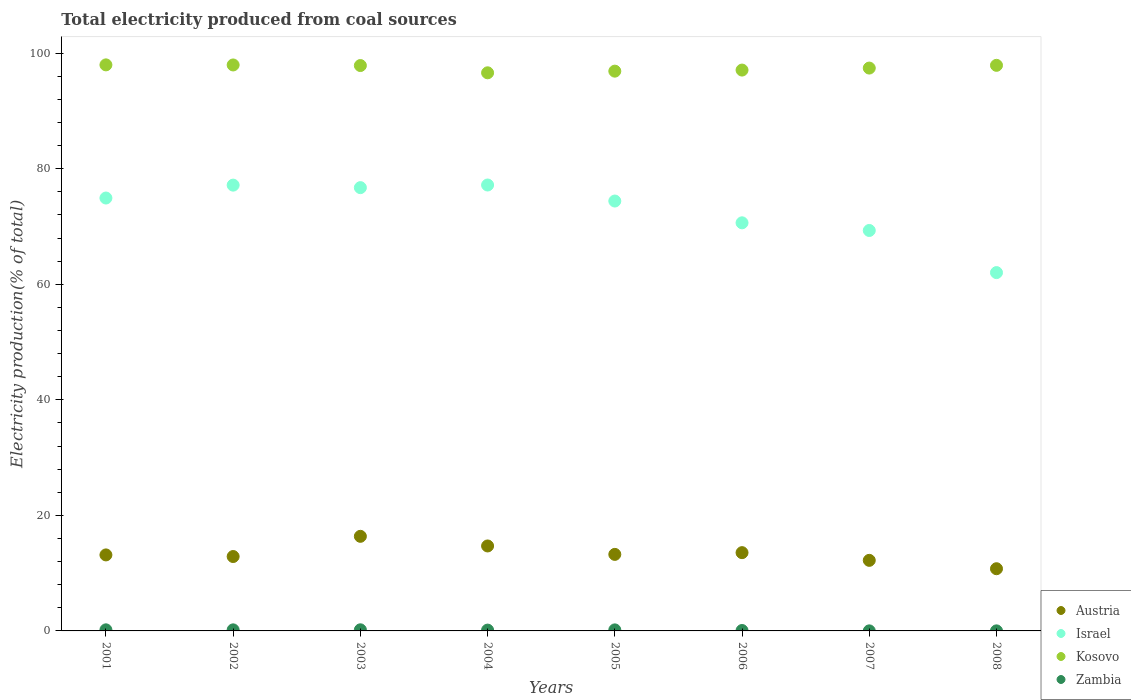What is the total electricity produced in Kosovo in 2007?
Keep it short and to the point. 97.41. Across all years, what is the maximum total electricity produced in Austria?
Make the answer very short. 16.37. Across all years, what is the minimum total electricity produced in Zambia?
Ensure brevity in your answer.  0.01. In which year was the total electricity produced in Austria minimum?
Provide a short and direct response. 2008. What is the total total electricity produced in Israel in the graph?
Provide a succinct answer. 582.33. What is the difference between the total electricity produced in Israel in 2001 and that in 2005?
Your answer should be very brief. 0.52. What is the difference between the total electricity produced in Zambia in 2002 and the total electricity produced in Israel in 2008?
Keep it short and to the point. -61.83. What is the average total electricity produced in Austria per year?
Give a very brief answer. 13.36. In the year 2005, what is the difference between the total electricity produced in Kosovo and total electricity produced in Austria?
Make the answer very short. 83.64. What is the ratio of the total electricity produced in Zambia in 2003 to that in 2004?
Give a very brief answer. 1.37. Is the difference between the total electricity produced in Kosovo in 2002 and 2006 greater than the difference between the total electricity produced in Austria in 2002 and 2006?
Give a very brief answer. Yes. What is the difference between the highest and the second highest total electricity produced in Kosovo?
Make the answer very short. 0.01. What is the difference between the highest and the lowest total electricity produced in Austria?
Give a very brief answer. 5.61. In how many years, is the total electricity produced in Kosovo greater than the average total electricity produced in Kosovo taken over all years?
Provide a succinct answer. 4. Is it the case that in every year, the sum of the total electricity produced in Austria and total electricity produced in Israel  is greater than the sum of total electricity produced in Zambia and total electricity produced in Kosovo?
Offer a very short reply. Yes. How many years are there in the graph?
Your answer should be compact. 8. What is the difference between two consecutive major ticks on the Y-axis?
Provide a short and direct response. 20. Are the values on the major ticks of Y-axis written in scientific E-notation?
Provide a succinct answer. No. Does the graph contain grids?
Give a very brief answer. No. Where does the legend appear in the graph?
Your answer should be very brief. Bottom right. How are the legend labels stacked?
Ensure brevity in your answer.  Vertical. What is the title of the graph?
Give a very brief answer. Total electricity produced from coal sources. Does "Bulgaria" appear as one of the legend labels in the graph?
Give a very brief answer. No. What is the label or title of the Y-axis?
Your answer should be compact. Electricity production(% of total). What is the Electricity production(% of total) in Austria in 2001?
Keep it short and to the point. 13.15. What is the Electricity production(% of total) in Israel in 2001?
Your response must be concise. 74.92. What is the Electricity production(% of total) of Kosovo in 2001?
Your answer should be very brief. 97.97. What is the Electricity production(% of total) in Zambia in 2001?
Ensure brevity in your answer.  0.19. What is the Electricity production(% of total) in Austria in 2002?
Offer a very short reply. 12.88. What is the Electricity production(% of total) in Israel in 2002?
Your response must be concise. 77.15. What is the Electricity production(% of total) of Kosovo in 2002?
Your response must be concise. 97.95. What is the Electricity production(% of total) of Zambia in 2002?
Offer a very short reply. 0.18. What is the Electricity production(% of total) of Austria in 2003?
Give a very brief answer. 16.37. What is the Electricity production(% of total) in Israel in 2003?
Keep it short and to the point. 76.72. What is the Electricity production(% of total) in Kosovo in 2003?
Provide a succinct answer. 97.85. What is the Electricity production(% of total) of Zambia in 2003?
Ensure brevity in your answer.  0.19. What is the Electricity production(% of total) of Austria in 2004?
Provide a short and direct response. 14.7. What is the Electricity production(% of total) in Israel in 2004?
Provide a short and direct response. 77.18. What is the Electricity production(% of total) of Kosovo in 2004?
Your answer should be very brief. 96.59. What is the Electricity production(% of total) in Zambia in 2004?
Your answer should be compact. 0.14. What is the Electricity production(% of total) in Austria in 2005?
Offer a terse response. 13.25. What is the Electricity production(% of total) of Israel in 2005?
Make the answer very short. 74.4. What is the Electricity production(% of total) in Kosovo in 2005?
Provide a succinct answer. 96.88. What is the Electricity production(% of total) of Zambia in 2005?
Keep it short and to the point. 0.18. What is the Electricity production(% of total) of Austria in 2006?
Your response must be concise. 13.55. What is the Electricity production(% of total) in Israel in 2006?
Offer a very short reply. 70.63. What is the Electricity production(% of total) in Kosovo in 2006?
Ensure brevity in your answer.  97.07. What is the Electricity production(% of total) in Zambia in 2006?
Your answer should be very brief. 0.07. What is the Electricity production(% of total) in Austria in 2007?
Ensure brevity in your answer.  12.21. What is the Electricity production(% of total) in Israel in 2007?
Give a very brief answer. 69.31. What is the Electricity production(% of total) of Kosovo in 2007?
Make the answer very short. 97.41. What is the Electricity production(% of total) in Zambia in 2007?
Ensure brevity in your answer.  0.01. What is the Electricity production(% of total) of Austria in 2008?
Offer a terse response. 10.76. What is the Electricity production(% of total) of Israel in 2008?
Ensure brevity in your answer.  62.02. What is the Electricity production(% of total) of Kosovo in 2008?
Offer a terse response. 97.89. What is the Electricity production(% of total) of Zambia in 2008?
Provide a succinct answer. 0.01. Across all years, what is the maximum Electricity production(% of total) of Austria?
Keep it short and to the point. 16.37. Across all years, what is the maximum Electricity production(% of total) in Israel?
Offer a very short reply. 77.18. Across all years, what is the maximum Electricity production(% of total) of Kosovo?
Offer a very short reply. 97.97. Across all years, what is the maximum Electricity production(% of total) in Zambia?
Provide a succinct answer. 0.19. Across all years, what is the minimum Electricity production(% of total) in Austria?
Offer a very short reply. 10.76. Across all years, what is the minimum Electricity production(% of total) of Israel?
Keep it short and to the point. 62.02. Across all years, what is the minimum Electricity production(% of total) in Kosovo?
Provide a succinct answer. 96.59. Across all years, what is the minimum Electricity production(% of total) in Zambia?
Offer a very short reply. 0.01. What is the total Electricity production(% of total) of Austria in the graph?
Your answer should be compact. 106.88. What is the total Electricity production(% of total) in Israel in the graph?
Keep it short and to the point. 582.33. What is the total Electricity production(% of total) in Kosovo in the graph?
Your response must be concise. 779.62. What is the total Electricity production(% of total) in Zambia in the graph?
Offer a very short reply. 0.98. What is the difference between the Electricity production(% of total) of Austria in 2001 and that in 2002?
Your response must be concise. 0.28. What is the difference between the Electricity production(% of total) in Israel in 2001 and that in 2002?
Provide a succinct answer. -2.23. What is the difference between the Electricity production(% of total) of Kosovo in 2001 and that in 2002?
Offer a terse response. 0.01. What is the difference between the Electricity production(% of total) of Zambia in 2001 and that in 2002?
Offer a very short reply. 0. What is the difference between the Electricity production(% of total) in Austria in 2001 and that in 2003?
Make the answer very short. -3.22. What is the difference between the Electricity production(% of total) in Israel in 2001 and that in 2003?
Keep it short and to the point. -1.8. What is the difference between the Electricity production(% of total) in Kosovo in 2001 and that in 2003?
Provide a short and direct response. 0.12. What is the difference between the Electricity production(% of total) in Zambia in 2001 and that in 2003?
Provide a succinct answer. -0. What is the difference between the Electricity production(% of total) of Austria in 2001 and that in 2004?
Provide a short and direct response. -1.55. What is the difference between the Electricity production(% of total) in Israel in 2001 and that in 2004?
Offer a terse response. -2.25. What is the difference between the Electricity production(% of total) of Kosovo in 2001 and that in 2004?
Make the answer very short. 1.37. What is the difference between the Electricity production(% of total) in Zambia in 2001 and that in 2004?
Offer a terse response. 0.05. What is the difference between the Electricity production(% of total) in Austria in 2001 and that in 2005?
Give a very brief answer. -0.09. What is the difference between the Electricity production(% of total) of Israel in 2001 and that in 2005?
Offer a very short reply. 0.52. What is the difference between the Electricity production(% of total) of Kosovo in 2001 and that in 2005?
Your response must be concise. 1.09. What is the difference between the Electricity production(% of total) of Zambia in 2001 and that in 2005?
Offer a very short reply. 0.01. What is the difference between the Electricity production(% of total) in Austria in 2001 and that in 2006?
Offer a very short reply. -0.39. What is the difference between the Electricity production(% of total) of Israel in 2001 and that in 2006?
Provide a succinct answer. 4.29. What is the difference between the Electricity production(% of total) of Kosovo in 2001 and that in 2006?
Offer a very short reply. 0.9. What is the difference between the Electricity production(% of total) in Zambia in 2001 and that in 2006?
Ensure brevity in your answer.  0.12. What is the difference between the Electricity production(% of total) in Austria in 2001 and that in 2007?
Offer a very short reply. 0.94. What is the difference between the Electricity production(% of total) of Israel in 2001 and that in 2007?
Provide a succinct answer. 5.62. What is the difference between the Electricity production(% of total) of Kosovo in 2001 and that in 2007?
Provide a succinct answer. 0.55. What is the difference between the Electricity production(% of total) of Zambia in 2001 and that in 2007?
Keep it short and to the point. 0.18. What is the difference between the Electricity production(% of total) in Austria in 2001 and that in 2008?
Keep it short and to the point. 2.39. What is the difference between the Electricity production(% of total) of Israel in 2001 and that in 2008?
Give a very brief answer. 12.91. What is the difference between the Electricity production(% of total) in Kosovo in 2001 and that in 2008?
Your answer should be compact. 0.08. What is the difference between the Electricity production(% of total) in Zambia in 2001 and that in 2008?
Provide a short and direct response. 0.18. What is the difference between the Electricity production(% of total) in Austria in 2002 and that in 2003?
Give a very brief answer. -3.5. What is the difference between the Electricity production(% of total) of Israel in 2002 and that in 2003?
Give a very brief answer. 0.43. What is the difference between the Electricity production(% of total) of Kosovo in 2002 and that in 2003?
Give a very brief answer. 0.1. What is the difference between the Electricity production(% of total) of Zambia in 2002 and that in 2003?
Make the answer very short. -0.01. What is the difference between the Electricity production(% of total) of Austria in 2002 and that in 2004?
Your answer should be very brief. -1.83. What is the difference between the Electricity production(% of total) in Israel in 2002 and that in 2004?
Offer a very short reply. -0.02. What is the difference between the Electricity production(% of total) in Kosovo in 2002 and that in 2004?
Offer a terse response. 1.36. What is the difference between the Electricity production(% of total) of Zambia in 2002 and that in 2004?
Your answer should be very brief. 0.04. What is the difference between the Electricity production(% of total) in Austria in 2002 and that in 2005?
Offer a very short reply. -0.37. What is the difference between the Electricity production(% of total) in Israel in 2002 and that in 2005?
Offer a terse response. 2.75. What is the difference between the Electricity production(% of total) of Kosovo in 2002 and that in 2005?
Give a very brief answer. 1.07. What is the difference between the Electricity production(% of total) of Zambia in 2002 and that in 2005?
Your answer should be very brief. 0.01. What is the difference between the Electricity production(% of total) in Austria in 2002 and that in 2006?
Offer a terse response. -0.67. What is the difference between the Electricity production(% of total) in Israel in 2002 and that in 2006?
Offer a very short reply. 6.52. What is the difference between the Electricity production(% of total) in Kosovo in 2002 and that in 2006?
Provide a succinct answer. 0.89. What is the difference between the Electricity production(% of total) of Zambia in 2002 and that in 2006?
Give a very brief answer. 0.11. What is the difference between the Electricity production(% of total) of Austria in 2002 and that in 2007?
Give a very brief answer. 0.66. What is the difference between the Electricity production(% of total) in Israel in 2002 and that in 2007?
Ensure brevity in your answer.  7.85. What is the difference between the Electricity production(% of total) of Kosovo in 2002 and that in 2007?
Your answer should be compact. 0.54. What is the difference between the Electricity production(% of total) of Zambia in 2002 and that in 2007?
Offer a terse response. 0.17. What is the difference between the Electricity production(% of total) of Austria in 2002 and that in 2008?
Ensure brevity in your answer.  2.11. What is the difference between the Electricity production(% of total) in Israel in 2002 and that in 2008?
Your answer should be compact. 15.14. What is the difference between the Electricity production(% of total) in Kosovo in 2002 and that in 2008?
Give a very brief answer. 0.07. What is the difference between the Electricity production(% of total) of Zambia in 2002 and that in 2008?
Ensure brevity in your answer.  0.17. What is the difference between the Electricity production(% of total) of Austria in 2003 and that in 2004?
Ensure brevity in your answer.  1.67. What is the difference between the Electricity production(% of total) in Israel in 2003 and that in 2004?
Your answer should be compact. -0.46. What is the difference between the Electricity production(% of total) of Kosovo in 2003 and that in 2004?
Make the answer very short. 1.26. What is the difference between the Electricity production(% of total) in Zambia in 2003 and that in 2004?
Your answer should be compact. 0.05. What is the difference between the Electricity production(% of total) of Austria in 2003 and that in 2005?
Provide a succinct answer. 3.13. What is the difference between the Electricity production(% of total) in Israel in 2003 and that in 2005?
Give a very brief answer. 2.32. What is the difference between the Electricity production(% of total) in Kosovo in 2003 and that in 2005?
Your response must be concise. 0.97. What is the difference between the Electricity production(% of total) of Zambia in 2003 and that in 2005?
Your answer should be very brief. 0.01. What is the difference between the Electricity production(% of total) in Austria in 2003 and that in 2006?
Ensure brevity in your answer.  2.83. What is the difference between the Electricity production(% of total) of Israel in 2003 and that in 2006?
Keep it short and to the point. 6.09. What is the difference between the Electricity production(% of total) of Kosovo in 2003 and that in 2006?
Give a very brief answer. 0.78. What is the difference between the Electricity production(% of total) in Zambia in 2003 and that in 2006?
Provide a succinct answer. 0.12. What is the difference between the Electricity production(% of total) of Austria in 2003 and that in 2007?
Your answer should be compact. 4.16. What is the difference between the Electricity production(% of total) in Israel in 2003 and that in 2007?
Give a very brief answer. 7.41. What is the difference between the Electricity production(% of total) in Kosovo in 2003 and that in 2007?
Your answer should be compact. 0.44. What is the difference between the Electricity production(% of total) in Zambia in 2003 and that in 2007?
Provide a succinct answer. 0.18. What is the difference between the Electricity production(% of total) of Austria in 2003 and that in 2008?
Offer a very short reply. 5.61. What is the difference between the Electricity production(% of total) in Israel in 2003 and that in 2008?
Provide a succinct answer. 14.7. What is the difference between the Electricity production(% of total) in Kosovo in 2003 and that in 2008?
Make the answer very short. -0.04. What is the difference between the Electricity production(% of total) in Zambia in 2003 and that in 2008?
Offer a very short reply. 0.18. What is the difference between the Electricity production(% of total) of Austria in 2004 and that in 2005?
Offer a very short reply. 1.46. What is the difference between the Electricity production(% of total) of Israel in 2004 and that in 2005?
Provide a succinct answer. 2.77. What is the difference between the Electricity production(% of total) of Kosovo in 2004 and that in 2005?
Offer a terse response. -0.29. What is the difference between the Electricity production(% of total) of Zambia in 2004 and that in 2005?
Ensure brevity in your answer.  -0.04. What is the difference between the Electricity production(% of total) of Austria in 2004 and that in 2006?
Your response must be concise. 1.16. What is the difference between the Electricity production(% of total) of Israel in 2004 and that in 2006?
Provide a succinct answer. 6.54. What is the difference between the Electricity production(% of total) of Kosovo in 2004 and that in 2006?
Your response must be concise. -0.47. What is the difference between the Electricity production(% of total) in Zambia in 2004 and that in 2006?
Give a very brief answer. 0.07. What is the difference between the Electricity production(% of total) of Austria in 2004 and that in 2007?
Offer a very short reply. 2.49. What is the difference between the Electricity production(% of total) of Israel in 2004 and that in 2007?
Provide a succinct answer. 7.87. What is the difference between the Electricity production(% of total) of Kosovo in 2004 and that in 2007?
Offer a very short reply. -0.82. What is the difference between the Electricity production(% of total) of Zambia in 2004 and that in 2007?
Your answer should be compact. 0.13. What is the difference between the Electricity production(% of total) in Austria in 2004 and that in 2008?
Give a very brief answer. 3.94. What is the difference between the Electricity production(% of total) of Israel in 2004 and that in 2008?
Your response must be concise. 15.16. What is the difference between the Electricity production(% of total) in Kosovo in 2004 and that in 2008?
Make the answer very short. -1.29. What is the difference between the Electricity production(% of total) of Zambia in 2004 and that in 2008?
Your answer should be compact. 0.13. What is the difference between the Electricity production(% of total) of Austria in 2005 and that in 2006?
Offer a terse response. -0.3. What is the difference between the Electricity production(% of total) of Israel in 2005 and that in 2006?
Keep it short and to the point. 3.77. What is the difference between the Electricity production(% of total) of Kosovo in 2005 and that in 2006?
Offer a very short reply. -0.19. What is the difference between the Electricity production(% of total) of Zambia in 2005 and that in 2006?
Provide a succinct answer. 0.11. What is the difference between the Electricity production(% of total) in Austria in 2005 and that in 2007?
Ensure brevity in your answer.  1.03. What is the difference between the Electricity production(% of total) of Israel in 2005 and that in 2007?
Your answer should be compact. 5.1. What is the difference between the Electricity production(% of total) in Kosovo in 2005 and that in 2007?
Provide a short and direct response. -0.53. What is the difference between the Electricity production(% of total) of Zambia in 2005 and that in 2007?
Offer a very short reply. 0.17. What is the difference between the Electricity production(% of total) in Austria in 2005 and that in 2008?
Give a very brief answer. 2.48. What is the difference between the Electricity production(% of total) of Israel in 2005 and that in 2008?
Provide a succinct answer. 12.39. What is the difference between the Electricity production(% of total) in Kosovo in 2005 and that in 2008?
Give a very brief answer. -1.01. What is the difference between the Electricity production(% of total) in Zambia in 2005 and that in 2008?
Give a very brief answer. 0.17. What is the difference between the Electricity production(% of total) in Austria in 2006 and that in 2007?
Provide a succinct answer. 1.33. What is the difference between the Electricity production(% of total) of Israel in 2006 and that in 2007?
Provide a succinct answer. 1.33. What is the difference between the Electricity production(% of total) in Kosovo in 2006 and that in 2007?
Ensure brevity in your answer.  -0.35. What is the difference between the Electricity production(% of total) in Zambia in 2006 and that in 2007?
Give a very brief answer. 0.06. What is the difference between the Electricity production(% of total) in Austria in 2006 and that in 2008?
Provide a succinct answer. 2.78. What is the difference between the Electricity production(% of total) in Israel in 2006 and that in 2008?
Ensure brevity in your answer.  8.62. What is the difference between the Electricity production(% of total) of Kosovo in 2006 and that in 2008?
Ensure brevity in your answer.  -0.82. What is the difference between the Electricity production(% of total) of Zambia in 2006 and that in 2008?
Offer a very short reply. 0.06. What is the difference between the Electricity production(% of total) of Austria in 2007 and that in 2008?
Provide a short and direct response. 1.45. What is the difference between the Electricity production(% of total) in Israel in 2007 and that in 2008?
Your response must be concise. 7.29. What is the difference between the Electricity production(% of total) in Kosovo in 2007 and that in 2008?
Provide a short and direct response. -0.47. What is the difference between the Electricity production(% of total) of Zambia in 2007 and that in 2008?
Make the answer very short. -0. What is the difference between the Electricity production(% of total) of Austria in 2001 and the Electricity production(% of total) of Israel in 2002?
Provide a succinct answer. -64. What is the difference between the Electricity production(% of total) of Austria in 2001 and the Electricity production(% of total) of Kosovo in 2002?
Keep it short and to the point. -84.8. What is the difference between the Electricity production(% of total) of Austria in 2001 and the Electricity production(% of total) of Zambia in 2002?
Give a very brief answer. 12.97. What is the difference between the Electricity production(% of total) of Israel in 2001 and the Electricity production(% of total) of Kosovo in 2002?
Your answer should be compact. -23.03. What is the difference between the Electricity production(% of total) of Israel in 2001 and the Electricity production(% of total) of Zambia in 2002?
Give a very brief answer. 74.74. What is the difference between the Electricity production(% of total) in Kosovo in 2001 and the Electricity production(% of total) in Zambia in 2002?
Offer a terse response. 97.78. What is the difference between the Electricity production(% of total) of Austria in 2001 and the Electricity production(% of total) of Israel in 2003?
Provide a short and direct response. -63.57. What is the difference between the Electricity production(% of total) of Austria in 2001 and the Electricity production(% of total) of Kosovo in 2003?
Keep it short and to the point. -84.7. What is the difference between the Electricity production(% of total) of Austria in 2001 and the Electricity production(% of total) of Zambia in 2003?
Give a very brief answer. 12.96. What is the difference between the Electricity production(% of total) of Israel in 2001 and the Electricity production(% of total) of Kosovo in 2003?
Provide a succinct answer. -22.93. What is the difference between the Electricity production(% of total) of Israel in 2001 and the Electricity production(% of total) of Zambia in 2003?
Provide a short and direct response. 74.73. What is the difference between the Electricity production(% of total) in Kosovo in 2001 and the Electricity production(% of total) in Zambia in 2003?
Give a very brief answer. 97.78. What is the difference between the Electricity production(% of total) of Austria in 2001 and the Electricity production(% of total) of Israel in 2004?
Offer a terse response. -64.02. What is the difference between the Electricity production(% of total) of Austria in 2001 and the Electricity production(% of total) of Kosovo in 2004?
Make the answer very short. -83.44. What is the difference between the Electricity production(% of total) in Austria in 2001 and the Electricity production(% of total) in Zambia in 2004?
Offer a terse response. 13.01. What is the difference between the Electricity production(% of total) of Israel in 2001 and the Electricity production(% of total) of Kosovo in 2004?
Provide a succinct answer. -21.67. What is the difference between the Electricity production(% of total) of Israel in 2001 and the Electricity production(% of total) of Zambia in 2004?
Keep it short and to the point. 74.78. What is the difference between the Electricity production(% of total) of Kosovo in 2001 and the Electricity production(% of total) of Zambia in 2004?
Make the answer very short. 97.83. What is the difference between the Electricity production(% of total) of Austria in 2001 and the Electricity production(% of total) of Israel in 2005?
Provide a short and direct response. -61.25. What is the difference between the Electricity production(% of total) in Austria in 2001 and the Electricity production(% of total) in Kosovo in 2005?
Provide a succinct answer. -83.73. What is the difference between the Electricity production(% of total) of Austria in 2001 and the Electricity production(% of total) of Zambia in 2005?
Your response must be concise. 12.98. What is the difference between the Electricity production(% of total) of Israel in 2001 and the Electricity production(% of total) of Kosovo in 2005?
Provide a short and direct response. -21.96. What is the difference between the Electricity production(% of total) in Israel in 2001 and the Electricity production(% of total) in Zambia in 2005?
Your answer should be very brief. 74.74. What is the difference between the Electricity production(% of total) of Kosovo in 2001 and the Electricity production(% of total) of Zambia in 2005?
Ensure brevity in your answer.  97.79. What is the difference between the Electricity production(% of total) in Austria in 2001 and the Electricity production(% of total) in Israel in 2006?
Offer a very short reply. -57.48. What is the difference between the Electricity production(% of total) in Austria in 2001 and the Electricity production(% of total) in Kosovo in 2006?
Provide a succinct answer. -83.91. What is the difference between the Electricity production(% of total) in Austria in 2001 and the Electricity production(% of total) in Zambia in 2006?
Your answer should be very brief. 13.08. What is the difference between the Electricity production(% of total) of Israel in 2001 and the Electricity production(% of total) of Kosovo in 2006?
Your answer should be compact. -22.15. What is the difference between the Electricity production(% of total) in Israel in 2001 and the Electricity production(% of total) in Zambia in 2006?
Provide a short and direct response. 74.85. What is the difference between the Electricity production(% of total) in Kosovo in 2001 and the Electricity production(% of total) in Zambia in 2006?
Give a very brief answer. 97.9. What is the difference between the Electricity production(% of total) in Austria in 2001 and the Electricity production(% of total) in Israel in 2007?
Make the answer very short. -56.15. What is the difference between the Electricity production(% of total) of Austria in 2001 and the Electricity production(% of total) of Kosovo in 2007?
Provide a short and direct response. -84.26. What is the difference between the Electricity production(% of total) in Austria in 2001 and the Electricity production(% of total) in Zambia in 2007?
Give a very brief answer. 13.14. What is the difference between the Electricity production(% of total) of Israel in 2001 and the Electricity production(% of total) of Kosovo in 2007?
Your answer should be compact. -22.49. What is the difference between the Electricity production(% of total) in Israel in 2001 and the Electricity production(% of total) in Zambia in 2007?
Offer a terse response. 74.91. What is the difference between the Electricity production(% of total) of Kosovo in 2001 and the Electricity production(% of total) of Zambia in 2007?
Your answer should be very brief. 97.96. What is the difference between the Electricity production(% of total) of Austria in 2001 and the Electricity production(% of total) of Israel in 2008?
Your answer should be compact. -48.86. What is the difference between the Electricity production(% of total) of Austria in 2001 and the Electricity production(% of total) of Kosovo in 2008?
Offer a very short reply. -84.73. What is the difference between the Electricity production(% of total) of Austria in 2001 and the Electricity production(% of total) of Zambia in 2008?
Your answer should be very brief. 13.14. What is the difference between the Electricity production(% of total) in Israel in 2001 and the Electricity production(% of total) in Kosovo in 2008?
Provide a short and direct response. -22.97. What is the difference between the Electricity production(% of total) of Israel in 2001 and the Electricity production(% of total) of Zambia in 2008?
Give a very brief answer. 74.91. What is the difference between the Electricity production(% of total) in Kosovo in 2001 and the Electricity production(% of total) in Zambia in 2008?
Your response must be concise. 97.96. What is the difference between the Electricity production(% of total) in Austria in 2002 and the Electricity production(% of total) in Israel in 2003?
Provide a succinct answer. -63.84. What is the difference between the Electricity production(% of total) in Austria in 2002 and the Electricity production(% of total) in Kosovo in 2003?
Ensure brevity in your answer.  -84.97. What is the difference between the Electricity production(% of total) of Austria in 2002 and the Electricity production(% of total) of Zambia in 2003?
Your answer should be very brief. 12.68. What is the difference between the Electricity production(% of total) of Israel in 2002 and the Electricity production(% of total) of Kosovo in 2003?
Offer a very short reply. -20.7. What is the difference between the Electricity production(% of total) in Israel in 2002 and the Electricity production(% of total) in Zambia in 2003?
Provide a short and direct response. 76.96. What is the difference between the Electricity production(% of total) in Kosovo in 2002 and the Electricity production(% of total) in Zambia in 2003?
Keep it short and to the point. 97.76. What is the difference between the Electricity production(% of total) of Austria in 2002 and the Electricity production(% of total) of Israel in 2004?
Offer a very short reply. -64.3. What is the difference between the Electricity production(% of total) in Austria in 2002 and the Electricity production(% of total) in Kosovo in 2004?
Offer a terse response. -83.72. What is the difference between the Electricity production(% of total) in Austria in 2002 and the Electricity production(% of total) in Zambia in 2004?
Your answer should be very brief. 12.74. What is the difference between the Electricity production(% of total) in Israel in 2002 and the Electricity production(% of total) in Kosovo in 2004?
Ensure brevity in your answer.  -19.44. What is the difference between the Electricity production(% of total) in Israel in 2002 and the Electricity production(% of total) in Zambia in 2004?
Your response must be concise. 77.01. What is the difference between the Electricity production(% of total) in Kosovo in 2002 and the Electricity production(% of total) in Zambia in 2004?
Your answer should be very brief. 97.81. What is the difference between the Electricity production(% of total) of Austria in 2002 and the Electricity production(% of total) of Israel in 2005?
Your answer should be compact. -61.53. What is the difference between the Electricity production(% of total) of Austria in 2002 and the Electricity production(% of total) of Kosovo in 2005?
Your answer should be compact. -84.01. What is the difference between the Electricity production(% of total) in Austria in 2002 and the Electricity production(% of total) in Zambia in 2005?
Make the answer very short. 12.7. What is the difference between the Electricity production(% of total) of Israel in 2002 and the Electricity production(% of total) of Kosovo in 2005?
Offer a very short reply. -19.73. What is the difference between the Electricity production(% of total) of Israel in 2002 and the Electricity production(% of total) of Zambia in 2005?
Your response must be concise. 76.97. What is the difference between the Electricity production(% of total) in Kosovo in 2002 and the Electricity production(% of total) in Zambia in 2005?
Make the answer very short. 97.78. What is the difference between the Electricity production(% of total) of Austria in 2002 and the Electricity production(% of total) of Israel in 2006?
Give a very brief answer. -57.75. What is the difference between the Electricity production(% of total) of Austria in 2002 and the Electricity production(% of total) of Kosovo in 2006?
Give a very brief answer. -84.19. What is the difference between the Electricity production(% of total) in Austria in 2002 and the Electricity production(% of total) in Zambia in 2006?
Your answer should be very brief. 12.81. What is the difference between the Electricity production(% of total) in Israel in 2002 and the Electricity production(% of total) in Kosovo in 2006?
Your response must be concise. -19.91. What is the difference between the Electricity production(% of total) in Israel in 2002 and the Electricity production(% of total) in Zambia in 2006?
Your response must be concise. 77.08. What is the difference between the Electricity production(% of total) in Kosovo in 2002 and the Electricity production(% of total) in Zambia in 2006?
Keep it short and to the point. 97.88. What is the difference between the Electricity production(% of total) in Austria in 2002 and the Electricity production(% of total) in Israel in 2007?
Provide a short and direct response. -56.43. What is the difference between the Electricity production(% of total) of Austria in 2002 and the Electricity production(% of total) of Kosovo in 2007?
Your answer should be very brief. -84.54. What is the difference between the Electricity production(% of total) in Austria in 2002 and the Electricity production(% of total) in Zambia in 2007?
Your answer should be very brief. 12.87. What is the difference between the Electricity production(% of total) in Israel in 2002 and the Electricity production(% of total) in Kosovo in 2007?
Ensure brevity in your answer.  -20.26. What is the difference between the Electricity production(% of total) of Israel in 2002 and the Electricity production(% of total) of Zambia in 2007?
Your answer should be very brief. 77.14. What is the difference between the Electricity production(% of total) in Kosovo in 2002 and the Electricity production(% of total) in Zambia in 2007?
Give a very brief answer. 97.94. What is the difference between the Electricity production(% of total) in Austria in 2002 and the Electricity production(% of total) in Israel in 2008?
Provide a succinct answer. -49.14. What is the difference between the Electricity production(% of total) of Austria in 2002 and the Electricity production(% of total) of Kosovo in 2008?
Provide a succinct answer. -85.01. What is the difference between the Electricity production(% of total) in Austria in 2002 and the Electricity production(% of total) in Zambia in 2008?
Make the answer very short. 12.87. What is the difference between the Electricity production(% of total) of Israel in 2002 and the Electricity production(% of total) of Kosovo in 2008?
Offer a very short reply. -20.73. What is the difference between the Electricity production(% of total) of Israel in 2002 and the Electricity production(% of total) of Zambia in 2008?
Make the answer very short. 77.14. What is the difference between the Electricity production(% of total) in Kosovo in 2002 and the Electricity production(% of total) in Zambia in 2008?
Make the answer very short. 97.94. What is the difference between the Electricity production(% of total) of Austria in 2003 and the Electricity production(% of total) of Israel in 2004?
Your answer should be compact. -60.8. What is the difference between the Electricity production(% of total) in Austria in 2003 and the Electricity production(% of total) in Kosovo in 2004?
Make the answer very short. -80.22. What is the difference between the Electricity production(% of total) of Austria in 2003 and the Electricity production(% of total) of Zambia in 2004?
Make the answer very short. 16.23. What is the difference between the Electricity production(% of total) in Israel in 2003 and the Electricity production(% of total) in Kosovo in 2004?
Provide a succinct answer. -19.87. What is the difference between the Electricity production(% of total) of Israel in 2003 and the Electricity production(% of total) of Zambia in 2004?
Your answer should be compact. 76.58. What is the difference between the Electricity production(% of total) of Kosovo in 2003 and the Electricity production(% of total) of Zambia in 2004?
Provide a succinct answer. 97.71. What is the difference between the Electricity production(% of total) of Austria in 2003 and the Electricity production(% of total) of Israel in 2005?
Your response must be concise. -58.03. What is the difference between the Electricity production(% of total) in Austria in 2003 and the Electricity production(% of total) in Kosovo in 2005?
Keep it short and to the point. -80.51. What is the difference between the Electricity production(% of total) of Austria in 2003 and the Electricity production(% of total) of Zambia in 2005?
Your answer should be very brief. 16.19. What is the difference between the Electricity production(% of total) of Israel in 2003 and the Electricity production(% of total) of Kosovo in 2005?
Your answer should be compact. -20.16. What is the difference between the Electricity production(% of total) in Israel in 2003 and the Electricity production(% of total) in Zambia in 2005?
Your response must be concise. 76.54. What is the difference between the Electricity production(% of total) in Kosovo in 2003 and the Electricity production(% of total) in Zambia in 2005?
Your answer should be very brief. 97.67. What is the difference between the Electricity production(% of total) in Austria in 2003 and the Electricity production(% of total) in Israel in 2006?
Your answer should be compact. -54.26. What is the difference between the Electricity production(% of total) in Austria in 2003 and the Electricity production(% of total) in Kosovo in 2006?
Ensure brevity in your answer.  -80.7. What is the difference between the Electricity production(% of total) in Austria in 2003 and the Electricity production(% of total) in Zambia in 2006?
Your answer should be very brief. 16.3. What is the difference between the Electricity production(% of total) in Israel in 2003 and the Electricity production(% of total) in Kosovo in 2006?
Give a very brief answer. -20.35. What is the difference between the Electricity production(% of total) in Israel in 2003 and the Electricity production(% of total) in Zambia in 2006?
Provide a short and direct response. 76.65. What is the difference between the Electricity production(% of total) in Kosovo in 2003 and the Electricity production(% of total) in Zambia in 2006?
Your answer should be very brief. 97.78. What is the difference between the Electricity production(% of total) of Austria in 2003 and the Electricity production(% of total) of Israel in 2007?
Your response must be concise. -52.93. What is the difference between the Electricity production(% of total) of Austria in 2003 and the Electricity production(% of total) of Kosovo in 2007?
Provide a short and direct response. -81.04. What is the difference between the Electricity production(% of total) of Austria in 2003 and the Electricity production(% of total) of Zambia in 2007?
Offer a very short reply. 16.36. What is the difference between the Electricity production(% of total) of Israel in 2003 and the Electricity production(% of total) of Kosovo in 2007?
Your answer should be very brief. -20.69. What is the difference between the Electricity production(% of total) in Israel in 2003 and the Electricity production(% of total) in Zambia in 2007?
Offer a terse response. 76.71. What is the difference between the Electricity production(% of total) of Kosovo in 2003 and the Electricity production(% of total) of Zambia in 2007?
Your response must be concise. 97.84. What is the difference between the Electricity production(% of total) of Austria in 2003 and the Electricity production(% of total) of Israel in 2008?
Your answer should be compact. -45.64. What is the difference between the Electricity production(% of total) in Austria in 2003 and the Electricity production(% of total) in Kosovo in 2008?
Make the answer very short. -81.52. What is the difference between the Electricity production(% of total) in Austria in 2003 and the Electricity production(% of total) in Zambia in 2008?
Make the answer very short. 16.36. What is the difference between the Electricity production(% of total) in Israel in 2003 and the Electricity production(% of total) in Kosovo in 2008?
Provide a succinct answer. -21.17. What is the difference between the Electricity production(% of total) in Israel in 2003 and the Electricity production(% of total) in Zambia in 2008?
Your answer should be compact. 76.71. What is the difference between the Electricity production(% of total) in Kosovo in 2003 and the Electricity production(% of total) in Zambia in 2008?
Give a very brief answer. 97.84. What is the difference between the Electricity production(% of total) of Austria in 2004 and the Electricity production(% of total) of Israel in 2005?
Offer a very short reply. -59.7. What is the difference between the Electricity production(% of total) in Austria in 2004 and the Electricity production(% of total) in Kosovo in 2005?
Ensure brevity in your answer.  -82.18. What is the difference between the Electricity production(% of total) of Austria in 2004 and the Electricity production(% of total) of Zambia in 2005?
Give a very brief answer. 14.53. What is the difference between the Electricity production(% of total) in Israel in 2004 and the Electricity production(% of total) in Kosovo in 2005?
Provide a short and direct response. -19.71. What is the difference between the Electricity production(% of total) of Israel in 2004 and the Electricity production(% of total) of Zambia in 2005?
Provide a succinct answer. 77. What is the difference between the Electricity production(% of total) of Kosovo in 2004 and the Electricity production(% of total) of Zambia in 2005?
Ensure brevity in your answer.  96.42. What is the difference between the Electricity production(% of total) of Austria in 2004 and the Electricity production(% of total) of Israel in 2006?
Ensure brevity in your answer.  -55.93. What is the difference between the Electricity production(% of total) in Austria in 2004 and the Electricity production(% of total) in Kosovo in 2006?
Give a very brief answer. -82.36. What is the difference between the Electricity production(% of total) of Austria in 2004 and the Electricity production(% of total) of Zambia in 2006?
Offer a very short reply. 14.63. What is the difference between the Electricity production(% of total) of Israel in 2004 and the Electricity production(% of total) of Kosovo in 2006?
Offer a very short reply. -19.89. What is the difference between the Electricity production(% of total) of Israel in 2004 and the Electricity production(% of total) of Zambia in 2006?
Provide a short and direct response. 77.11. What is the difference between the Electricity production(% of total) of Kosovo in 2004 and the Electricity production(% of total) of Zambia in 2006?
Your answer should be compact. 96.52. What is the difference between the Electricity production(% of total) in Austria in 2004 and the Electricity production(% of total) in Israel in 2007?
Provide a short and direct response. -54.6. What is the difference between the Electricity production(% of total) in Austria in 2004 and the Electricity production(% of total) in Kosovo in 2007?
Give a very brief answer. -82.71. What is the difference between the Electricity production(% of total) of Austria in 2004 and the Electricity production(% of total) of Zambia in 2007?
Give a very brief answer. 14.69. What is the difference between the Electricity production(% of total) of Israel in 2004 and the Electricity production(% of total) of Kosovo in 2007?
Offer a very short reply. -20.24. What is the difference between the Electricity production(% of total) in Israel in 2004 and the Electricity production(% of total) in Zambia in 2007?
Keep it short and to the point. 77.17. What is the difference between the Electricity production(% of total) in Kosovo in 2004 and the Electricity production(% of total) in Zambia in 2007?
Offer a terse response. 96.58. What is the difference between the Electricity production(% of total) in Austria in 2004 and the Electricity production(% of total) in Israel in 2008?
Your answer should be compact. -47.31. What is the difference between the Electricity production(% of total) in Austria in 2004 and the Electricity production(% of total) in Kosovo in 2008?
Ensure brevity in your answer.  -83.18. What is the difference between the Electricity production(% of total) in Austria in 2004 and the Electricity production(% of total) in Zambia in 2008?
Provide a succinct answer. 14.69. What is the difference between the Electricity production(% of total) in Israel in 2004 and the Electricity production(% of total) in Kosovo in 2008?
Your response must be concise. -20.71. What is the difference between the Electricity production(% of total) in Israel in 2004 and the Electricity production(% of total) in Zambia in 2008?
Keep it short and to the point. 77.17. What is the difference between the Electricity production(% of total) of Kosovo in 2004 and the Electricity production(% of total) of Zambia in 2008?
Your response must be concise. 96.58. What is the difference between the Electricity production(% of total) in Austria in 2005 and the Electricity production(% of total) in Israel in 2006?
Your response must be concise. -57.39. What is the difference between the Electricity production(% of total) in Austria in 2005 and the Electricity production(% of total) in Kosovo in 2006?
Your response must be concise. -83.82. What is the difference between the Electricity production(% of total) of Austria in 2005 and the Electricity production(% of total) of Zambia in 2006?
Make the answer very short. 13.17. What is the difference between the Electricity production(% of total) in Israel in 2005 and the Electricity production(% of total) in Kosovo in 2006?
Keep it short and to the point. -22.67. What is the difference between the Electricity production(% of total) of Israel in 2005 and the Electricity production(% of total) of Zambia in 2006?
Provide a succinct answer. 74.33. What is the difference between the Electricity production(% of total) in Kosovo in 2005 and the Electricity production(% of total) in Zambia in 2006?
Give a very brief answer. 96.81. What is the difference between the Electricity production(% of total) of Austria in 2005 and the Electricity production(% of total) of Israel in 2007?
Offer a very short reply. -56.06. What is the difference between the Electricity production(% of total) of Austria in 2005 and the Electricity production(% of total) of Kosovo in 2007?
Make the answer very short. -84.17. What is the difference between the Electricity production(% of total) of Austria in 2005 and the Electricity production(% of total) of Zambia in 2007?
Give a very brief answer. 13.24. What is the difference between the Electricity production(% of total) in Israel in 2005 and the Electricity production(% of total) in Kosovo in 2007?
Your answer should be very brief. -23.01. What is the difference between the Electricity production(% of total) of Israel in 2005 and the Electricity production(% of total) of Zambia in 2007?
Give a very brief answer. 74.39. What is the difference between the Electricity production(% of total) of Kosovo in 2005 and the Electricity production(% of total) of Zambia in 2007?
Make the answer very short. 96.87. What is the difference between the Electricity production(% of total) in Austria in 2005 and the Electricity production(% of total) in Israel in 2008?
Your response must be concise. -48.77. What is the difference between the Electricity production(% of total) of Austria in 2005 and the Electricity production(% of total) of Kosovo in 2008?
Your answer should be compact. -84.64. What is the difference between the Electricity production(% of total) of Austria in 2005 and the Electricity production(% of total) of Zambia in 2008?
Keep it short and to the point. 13.24. What is the difference between the Electricity production(% of total) of Israel in 2005 and the Electricity production(% of total) of Kosovo in 2008?
Your response must be concise. -23.49. What is the difference between the Electricity production(% of total) of Israel in 2005 and the Electricity production(% of total) of Zambia in 2008?
Give a very brief answer. 74.39. What is the difference between the Electricity production(% of total) of Kosovo in 2005 and the Electricity production(% of total) of Zambia in 2008?
Offer a terse response. 96.87. What is the difference between the Electricity production(% of total) of Austria in 2006 and the Electricity production(% of total) of Israel in 2007?
Your answer should be very brief. -55.76. What is the difference between the Electricity production(% of total) of Austria in 2006 and the Electricity production(% of total) of Kosovo in 2007?
Give a very brief answer. -83.87. What is the difference between the Electricity production(% of total) in Austria in 2006 and the Electricity production(% of total) in Zambia in 2007?
Ensure brevity in your answer.  13.54. What is the difference between the Electricity production(% of total) of Israel in 2006 and the Electricity production(% of total) of Kosovo in 2007?
Your answer should be very brief. -26.78. What is the difference between the Electricity production(% of total) of Israel in 2006 and the Electricity production(% of total) of Zambia in 2007?
Your answer should be very brief. 70.62. What is the difference between the Electricity production(% of total) of Kosovo in 2006 and the Electricity production(% of total) of Zambia in 2007?
Offer a terse response. 97.06. What is the difference between the Electricity production(% of total) of Austria in 2006 and the Electricity production(% of total) of Israel in 2008?
Your response must be concise. -48.47. What is the difference between the Electricity production(% of total) in Austria in 2006 and the Electricity production(% of total) in Kosovo in 2008?
Offer a terse response. -84.34. What is the difference between the Electricity production(% of total) in Austria in 2006 and the Electricity production(% of total) in Zambia in 2008?
Give a very brief answer. 13.54. What is the difference between the Electricity production(% of total) of Israel in 2006 and the Electricity production(% of total) of Kosovo in 2008?
Ensure brevity in your answer.  -27.26. What is the difference between the Electricity production(% of total) in Israel in 2006 and the Electricity production(% of total) in Zambia in 2008?
Your answer should be very brief. 70.62. What is the difference between the Electricity production(% of total) in Kosovo in 2006 and the Electricity production(% of total) in Zambia in 2008?
Offer a very short reply. 97.06. What is the difference between the Electricity production(% of total) in Austria in 2007 and the Electricity production(% of total) in Israel in 2008?
Your answer should be very brief. -49.8. What is the difference between the Electricity production(% of total) in Austria in 2007 and the Electricity production(% of total) in Kosovo in 2008?
Your answer should be compact. -85.68. What is the difference between the Electricity production(% of total) in Austria in 2007 and the Electricity production(% of total) in Zambia in 2008?
Make the answer very short. 12.2. What is the difference between the Electricity production(% of total) of Israel in 2007 and the Electricity production(% of total) of Kosovo in 2008?
Give a very brief answer. -28.58. What is the difference between the Electricity production(% of total) of Israel in 2007 and the Electricity production(% of total) of Zambia in 2008?
Provide a succinct answer. 69.3. What is the difference between the Electricity production(% of total) in Kosovo in 2007 and the Electricity production(% of total) in Zambia in 2008?
Make the answer very short. 97.4. What is the average Electricity production(% of total) in Austria per year?
Ensure brevity in your answer.  13.36. What is the average Electricity production(% of total) in Israel per year?
Your answer should be compact. 72.79. What is the average Electricity production(% of total) in Kosovo per year?
Provide a succinct answer. 97.45. What is the average Electricity production(% of total) of Zambia per year?
Provide a short and direct response. 0.12. In the year 2001, what is the difference between the Electricity production(% of total) in Austria and Electricity production(% of total) in Israel?
Your answer should be compact. -61.77. In the year 2001, what is the difference between the Electricity production(% of total) in Austria and Electricity production(% of total) in Kosovo?
Offer a very short reply. -84.81. In the year 2001, what is the difference between the Electricity production(% of total) in Austria and Electricity production(% of total) in Zambia?
Offer a terse response. 12.97. In the year 2001, what is the difference between the Electricity production(% of total) in Israel and Electricity production(% of total) in Kosovo?
Ensure brevity in your answer.  -23.05. In the year 2001, what is the difference between the Electricity production(% of total) of Israel and Electricity production(% of total) of Zambia?
Ensure brevity in your answer.  74.73. In the year 2001, what is the difference between the Electricity production(% of total) of Kosovo and Electricity production(% of total) of Zambia?
Offer a terse response. 97.78. In the year 2002, what is the difference between the Electricity production(% of total) of Austria and Electricity production(% of total) of Israel?
Give a very brief answer. -64.28. In the year 2002, what is the difference between the Electricity production(% of total) in Austria and Electricity production(% of total) in Kosovo?
Make the answer very short. -85.08. In the year 2002, what is the difference between the Electricity production(% of total) in Austria and Electricity production(% of total) in Zambia?
Your answer should be very brief. 12.69. In the year 2002, what is the difference between the Electricity production(% of total) of Israel and Electricity production(% of total) of Kosovo?
Your answer should be very brief. -20.8. In the year 2002, what is the difference between the Electricity production(% of total) in Israel and Electricity production(% of total) in Zambia?
Keep it short and to the point. 76.97. In the year 2002, what is the difference between the Electricity production(% of total) of Kosovo and Electricity production(% of total) of Zambia?
Offer a terse response. 97.77. In the year 2003, what is the difference between the Electricity production(% of total) in Austria and Electricity production(% of total) in Israel?
Your answer should be very brief. -60.35. In the year 2003, what is the difference between the Electricity production(% of total) of Austria and Electricity production(% of total) of Kosovo?
Ensure brevity in your answer.  -81.48. In the year 2003, what is the difference between the Electricity production(% of total) in Austria and Electricity production(% of total) in Zambia?
Your response must be concise. 16.18. In the year 2003, what is the difference between the Electricity production(% of total) of Israel and Electricity production(% of total) of Kosovo?
Offer a very short reply. -21.13. In the year 2003, what is the difference between the Electricity production(% of total) in Israel and Electricity production(% of total) in Zambia?
Offer a terse response. 76.53. In the year 2003, what is the difference between the Electricity production(% of total) of Kosovo and Electricity production(% of total) of Zambia?
Give a very brief answer. 97.66. In the year 2004, what is the difference between the Electricity production(% of total) in Austria and Electricity production(% of total) in Israel?
Ensure brevity in your answer.  -62.47. In the year 2004, what is the difference between the Electricity production(% of total) in Austria and Electricity production(% of total) in Kosovo?
Offer a terse response. -81.89. In the year 2004, what is the difference between the Electricity production(% of total) of Austria and Electricity production(% of total) of Zambia?
Make the answer very short. 14.56. In the year 2004, what is the difference between the Electricity production(% of total) of Israel and Electricity production(% of total) of Kosovo?
Provide a succinct answer. -19.42. In the year 2004, what is the difference between the Electricity production(% of total) in Israel and Electricity production(% of total) in Zambia?
Provide a short and direct response. 77.03. In the year 2004, what is the difference between the Electricity production(% of total) in Kosovo and Electricity production(% of total) in Zambia?
Your response must be concise. 96.45. In the year 2005, what is the difference between the Electricity production(% of total) of Austria and Electricity production(% of total) of Israel?
Your answer should be very brief. -61.16. In the year 2005, what is the difference between the Electricity production(% of total) in Austria and Electricity production(% of total) in Kosovo?
Make the answer very short. -83.64. In the year 2005, what is the difference between the Electricity production(% of total) in Austria and Electricity production(% of total) in Zambia?
Offer a terse response. 13.07. In the year 2005, what is the difference between the Electricity production(% of total) of Israel and Electricity production(% of total) of Kosovo?
Your answer should be compact. -22.48. In the year 2005, what is the difference between the Electricity production(% of total) of Israel and Electricity production(% of total) of Zambia?
Your answer should be very brief. 74.22. In the year 2005, what is the difference between the Electricity production(% of total) of Kosovo and Electricity production(% of total) of Zambia?
Ensure brevity in your answer.  96.7. In the year 2006, what is the difference between the Electricity production(% of total) of Austria and Electricity production(% of total) of Israel?
Your response must be concise. -57.09. In the year 2006, what is the difference between the Electricity production(% of total) in Austria and Electricity production(% of total) in Kosovo?
Provide a succinct answer. -83.52. In the year 2006, what is the difference between the Electricity production(% of total) in Austria and Electricity production(% of total) in Zambia?
Keep it short and to the point. 13.48. In the year 2006, what is the difference between the Electricity production(% of total) of Israel and Electricity production(% of total) of Kosovo?
Offer a very short reply. -26.44. In the year 2006, what is the difference between the Electricity production(% of total) of Israel and Electricity production(% of total) of Zambia?
Your answer should be very brief. 70.56. In the year 2006, what is the difference between the Electricity production(% of total) in Kosovo and Electricity production(% of total) in Zambia?
Make the answer very short. 97. In the year 2007, what is the difference between the Electricity production(% of total) in Austria and Electricity production(% of total) in Israel?
Provide a short and direct response. -57.09. In the year 2007, what is the difference between the Electricity production(% of total) in Austria and Electricity production(% of total) in Kosovo?
Your response must be concise. -85.2. In the year 2007, what is the difference between the Electricity production(% of total) of Austria and Electricity production(% of total) of Zambia?
Your answer should be very brief. 12.2. In the year 2007, what is the difference between the Electricity production(% of total) in Israel and Electricity production(% of total) in Kosovo?
Your answer should be very brief. -28.11. In the year 2007, what is the difference between the Electricity production(% of total) of Israel and Electricity production(% of total) of Zambia?
Your answer should be compact. 69.3. In the year 2007, what is the difference between the Electricity production(% of total) of Kosovo and Electricity production(% of total) of Zambia?
Give a very brief answer. 97.4. In the year 2008, what is the difference between the Electricity production(% of total) of Austria and Electricity production(% of total) of Israel?
Your response must be concise. -51.25. In the year 2008, what is the difference between the Electricity production(% of total) in Austria and Electricity production(% of total) in Kosovo?
Offer a very short reply. -87.12. In the year 2008, what is the difference between the Electricity production(% of total) of Austria and Electricity production(% of total) of Zambia?
Keep it short and to the point. 10.75. In the year 2008, what is the difference between the Electricity production(% of total) in Israel and Electricity production(% of total) in Kosovo?
Make the answer very short. -35.87. In the year 2008, what is the difference between the Electricity production(% of total) of Israel and Electricity production(% of total) of Zambia?
Offer a very short reply. 62.01. In the year 2008, what is the difference between the Electricity production(% of total) of Kosovo and Electricity production(% of total) of Zambia?
Offer a terse response. 97.88. What is the ratio of the Electricity production(% of total) in Austria in 2001 to that in 2002?
Provide a succinct answer. 1.02. What is the ratio of the Electricity production(% of total) of Israel in 2001 to that in 2002?
Ensure brevity in your answer.  0.97. What is the ratio of the Electricity production(% of total) of Kosovo in 2001 to that in 2002?
Offer a very short reply. 1. What is the ratio of the Electricity production(% of total) of Zambia in 2001 to that in 2002?
Provide a short and direct response. 1.03. What is the ratio of the Electricity production(% of total) of Austria in 2001 to that in 2003?
Make the answer very short. 0.8. What is the ratio of the Electricity production(% of total) in Israel in 2001 to that in 2003?
Make the answer very short. 0.98. What is the ratio of the Electricity production(% of total) in Zambia in 2001 to that in 2003?
Keep it short and to the point. 0.98. What is the ratio of the Electricity production(% of total) of Austria in 2001 to that in 2004?
Provide a succinct answer. 0.89. What is the ratio of the Electricity production(% of total) of Israel in 2001 to that in 2004?
Give a very brief answer. 0.97. What is the ratio of the Electricity production(% of total) of Kosovo in 2001 to that in 2004?
Provide a succinct answer. 1.01. What is the ratio of the Electricity production(% of total) of Zambia in 2001 to that in 2004?
Give a very brief answer. 1.34. What is the ratio of the Electricity production(% of total) of Kosovo in 2001 to that in 2005?
Your answer should be very brief. 1.01. What is the ratio of the Electricity production(% of total) of Zambia in 2001 to that in 2005?
Your answer should be very brief. 1.05. What is the ratio of the Electricity production(% of total) of Austria in 2001 to that in 2006?
Make the answer very short. 0.97. What is the ratio of the Electricity production(% of total) in Israel in 2001 to that in 2006?
Give a very brief answer. 1.06. What is the ratio of the Electricity production(% of total) in Kosovo in 2001 to that in 2006?
Your answer should be compact. 1.01. What is the ratio of the Electricity production(% of total) in Zambia in 2001 to that in 2006?
Give a very brief answer. 2.67. What is the ratio of the Electricity production(% of total) in Austria in 2001 to that in 2007?
Your answer should be very brief. 1.08. What is the ratio of the Electricity production(% of total) in Israel in 2001 to that in 2007?
Provide a short and direct response. 1.08. What is the ratio of the Electricity production(% of total) of Zambia in 2001 to that in 2007?
Ensure brevity in your answer.  18.56. What is the ratio of the Electricity production(% of total) in Austria in 2001 to that in 2008?
Give a very brief answer. 1.22. What is the ratio of the Electricity production(% of total) of Israel in 2001 to that in 2008?
Provide a succinct answer. 1.21. What is the ratio of the Electricity production(% of total) in Kosovo in 2001 to that in 2008?
Give a very brief answer. 1. What is the ratio of the Electricity production(% of total) of Zambia in 2001 to that in 2008?
Your answer should be very brief. 18.31. What is the ratio of the Electricity production(% of total) in Austria in 2002 to that in 2003?
Keep it short and to the point. 0.79. What is the ratio of the Electricity production(% of total) of Kosovo in 2002 to that in 2003?
Your answer should be compact. 1. What is the ratio of the Electricity production(% of total) of Zambia in 2002 to that in 2003?
Provide a short and direct response. 0.96. What is the ratio of the Electricity production(% of total) in Austria in 2002 to that in 2004?
Provide a succinct answer. 0.88. What is the ratio of the Electricity production(% of total) of Kosovo in 2002 to that in 2004?
Offer a very short reply. 1.01. What is the ratio of the Electricity production(% of total) in Zambia in 2002 to that in 2004?
Give a very brief answer. 1.3. What is the ratio of the Electricity production(% of total) in Austria in 2002 to that in 2005?
Make the answer very short. 0.97. What is the ratio of the Electricity production(% of total) of Kosovo in 2002 to that in 2005?
Keep it short and to the point. 1.01. What is the ratio of the Electricity production(% of total) in Zambia in 2002 to that in 2005?
Provide a succinct answer. 1.03. What is the ratio of the Electricity production(% of total) of Austria in 2002 to that in 2006?
Your answer should be very brief. 0.95. What is the ratio of the Electricity production(% of total) of Israel in 2002 to that in 2006?
Your answer should be very brief. 1.09. What is the ratio of the Electricity production(% of total) in Kosovo in 2002 to that in 2006?
Your answer should be compact. 1.01. What is the ratio of the Electricity production(% of total) of Zambia in 2002 to that in 2006?
Provide a short and direct response. 2.6. What is the ratio of the Electricity production(% of total) in Austria in 2002 to that in 2007?
Your answer should be very brief. 1.05. What is the ratio of the Electricity production(% of total) of Israel in 2002 to that in 2007?
Make the answer very short. 1.11. What is the ratio of the Electricity production(% of total) of Zambia in 2002 to that in 2007?
Your answer should be compact. 18.08. What is the ratio of the Electricity production(% of total) of Austria in 2002 to that in 2008?
Give a very brief answer. 1.2. What is the ratio of the Electricity production(% of total) of Israel in 2002 to that in 2008?
Provide a short and direct response. 1.24. What is the ratio of the Electricity production(% of total) of Zambia in 2002 to that in 2008?
Make the answer very short. 17.84. What is the ratio of the Electricity production(% of total) of Austria in 2003 to that in 2004?
Keep it short and to the point. 1.11. What is the ratio of the Electricity production(% of total) of Israel in 2003 to that in 2004?
Provide a succinct answer. 0.99. What is the ratio of the Electricity production(% of total) in Kosovo in 2003 to that in 2004?
Your response must be concise. 1.01. What is the ratio of the Electricity production(% of total) in Zambia in 2003 to that in 2004?
Keep it short and to the point. 1.37. What is the ratio of the Electricity production(% of total) in Austria in 2003 to that in 2005?
Make the answer very short. 1.24. What is the ratio of the Electricity production(% of total) of Israel in 2003 to that in 2005?
Give a very brief answer. 1.03. What is the ratio of the Electricity production(% of total) in Kosovo in 2003 to that in 2005?
Make the answer very short. 1.01. What is the ratio of the Electricity production(% of total) of Zambia in 2003 to that in 2005?
Your response must be concise. 1.08. What is the ratio of the Electricity production(% of total) in Austria in 2003 to that in 2006?
Provide a short and direct response. 1.21. What is the ratio of the Electricity production(% of total) of Israel in 2003 to that in 2006?
Keep it short and to the point. 1.09. What is the ratio of the Electricity production(% of total) of Kosovo in 2003 to that in 2006?
Your response must be concise. 1.01. What is the ratio of the Electricity production(% of total) in Zambia in 2003 to that in 2006?
Provide a succinct answer. 2.72. What is the ratio of the Electricity production(% of total) of Austria in 2003 to that in 2007?
Your answer should be very brief. 1.34. What is the ratio of the Electricity production(% of total) of Israel in 2003 to that in 2007?
Your response must be concise. 1.11. What is the ratio of the Electricity production(% of total) in Zambia in 2003 to that in 2007?
Ensure brevity in your answer.  18.93. What is the ratio of the Electricity production(% of total) in Austria in 2003 to that in 2008?
Ensure brevity in your answer.  1.52. What is the ratio of the Electricity production(% of total) in Israel in 2003 to that in 2008?
Your answer should be compact. 1.24. What is the ratio of the Electricity production(% of total) of Kosovo in 2003 to that in 2008?
Provide a succinct answer. 1. What is the ratio of the Electricity production(% of total) in Zambia in 2003 to that in 2008?
Make the answer very short. 18.67. What is the ratio of the Electricity production(% of total) in Austria in 2004 to that in 2005?
Give a very brief answer. 1.11. What is the ratio of the Electricity production(% of total) of Israel in 2004 to that in 2005?
Provide a short and direct response. 1.04. What is the ratio of the Electricity production(% of total) of Kosovo in 2004 to that in 2005?
Offer a very short reply. 1. What is the ratio of the Electricity production(% of total) of Zambia in 2004 to that in 2005?
Your answer should be compact. 0.79. What is the ratio of the Electricity production(% of total) of Austria in 2004 to that in 2006?
Make the answer very short. 1.09. What is the ratio of the Electricity production(% of total) in Israel in 2004 to that in 2006?
Your response must be concise. 1.09. What is the ratio of the Electricity production(% of total) of Zambia in 2004 to that in 2006?
Give a very brief answer. 1.99. What is the ratio of the Electricity production(% of total) in Austria in 2004 to that in 2007?
Your answer should be very brief. 1.2. What is the ratio of the Electricity production(% of total) in Israel in 2004 to that in 2007?
Provide a succinct answer. 1.11. What is the ratio of the Electricity production(% of total) in Kosovo in 2004 to that in 2007?
Offer a very short reply. 0.99. What is the ratio of the Electricity production(% of total) of Zambia in 2004 to that in 2007?
Your response must be concise. 13.86. What is the ratio of the Electricity production(% of total) in Austria in 2004 to that in 2008?
Provide a succinct answer. 1.37. What is the ratio of the Electricity production(% of total) in Israel in 2004 to that in 2008?
Your answer should be very brief. 1.24. What is the ratio of the Electricity production(% of total) in Zambia in 2004 to that in 2008?
Ensure brevity in your answer.  13.68. What is the ratio of the Electricity production(% of total) in Austria in 2005 to that in 2006?
Keep it short and to the point. 0.98. What is the ratio of the Electricity production(% of total) in Israel in 2005 to that in 2006?
Give a very brief answer. 1.05. What is the ratio of the Electricity production(% of total) of Zambia in 2005 to that in 2006?
Provide a succinct answer. 2.53. What is the ratio of the Electricity production(% of total) of Austria in 2005 to that in 2007?
Provide a succinct answer. 1.08. What is the ratio of the Electricity production(% of total) in Israel in 2005 to that in 2007?
Your answer should be very brief. 1.07. What is the ratio of the Electricity production(% of total) in Kosovo in 2005 to that in 2007?
Keep it short and to the point. 0.99. What is the ratio of the Electricity production(% of total) in Zambia in 2005 to that in 2007?
Offer a very short reply. 17.6. What is the ratio of the Electricity production(% of total) in Austria in 2005 to that in 2008?
Your answer should be compact. 1.23. What is the ratio of the Electricity production(% of total) of Israel in 2005 to that in 2008?
Your response must be concise. 1.2. What is the ratio of the Electricity production(% of total) in Kosovo in 2005 to that in 2008?
Offer a very short reply. 0.99. What is the ratio of the Electricity production(% of total) in Zambia in 2005 to that in 2008?
Your answer should be very brief. 17.36. What is the ratio of the Electricity production(% of total) in Austria in 2006 to that in 2007?
Make the answer very short. 1.11. What is the ratio of the Electricity production(% of total) in Israel in 2006 to that in 2007?
Ensure brevity in your answer.  1.02. What is the ratio of the Electricity production(% of total) of Zambia in 2006 to that in 2007?
Offer a very short reply. 6.96. What is the ratio of the Electricity production(% of total) in Austria in 2006 to that in 2008?
Offer a terse response. 1.26. What is the ratio of the Electricity production(% of total) of Israel in 2006 to that in 2008?
Offer a very short reply. 1.14. What is the ratio of the Electricity production(% of total) of Kosovo in 2006 to that in 2008?
Your answer should be very brief. 0.99. What is the ratio of the Electricity production(% of total) in Zambia in 2006 to that in 2008?
Your answer should be compact. 6.86. What is the ratio of the Electricity production(% of total) in Austria in 2007 to that in 2008?
Your answer should be very brief. 1.13. What is the ratio of the Electricity production(% of total) of Israel in 2007 to that in 2008?
Offer a terse response. 1.12. What is the ratio of the Electricity production(% of total) of Zambia in 2007 to that in 2008?
Offer a very short reply. 0.99. What is the difference between the highest and the second highest Electricity production(% of total) of Austria?
Offer a terse response. 1.67. What is the difference between the highest and the second highest Electricity production(% of total) in Israel?
Your answer should be compact. 0.02. What is the difference between the highest and the second highest Electricity production(% of total) in Kosovo?
Offer a terse response. 0.01. What is the difference between the highest and the second highest Electricity production(% of total) in Zambia?
Provide a short and direct response. 0. What is the difference between the highest and the lowest Electricity production(% of total) in Austria?
Keep it short and to the point. 5.61. What is the difference between the highest and the lowest Electricity production(% of total) in Israel?
Ensure brevity in your answer.  15.16. What is the difference between the highest and the lowest Electricity production(% of total) in Kosovo?
Offer a very short reply. 1.37. What is the difference between the highest and the lowest Electricity production(% of total) of Zambia?
Keep it short and to the point. 0.18. 